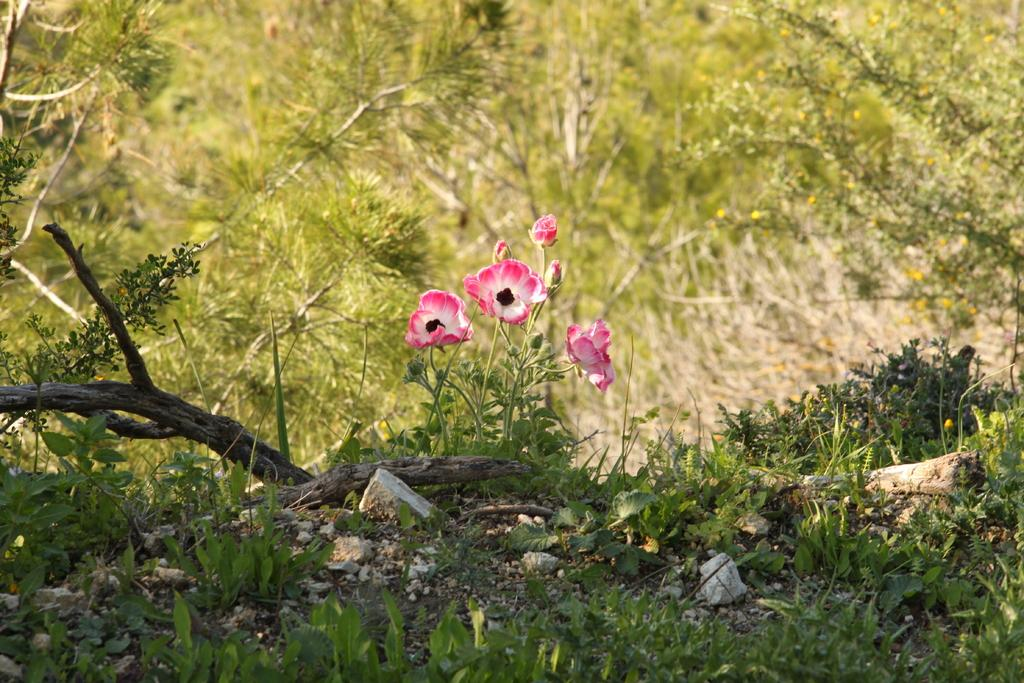What type of living organisms can be seen in the image? Plants can be seen in the image. What specific feature is present in the middle of the image? There are flowers in the middle of the image. What type of wound can be seen on the leaves of the plants in the image? There is no wound visible on the leaves of the plants in the image. 